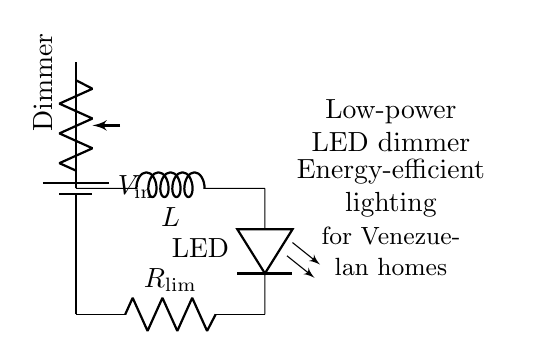What type of circuit is shown? The circuit presented is a dimmer circuit, specifically designed for controlling the brightness of an LED. It uses resistors and inductors to achieve dimming while conserving energy.
Answer: dimmer circuit What component limits the current to the LED? The component that limits the current flowing into the LED is the resistor specifically labeled as a current-limiting resistor. It ensures that the LED operates within safe current levels.
Answer: current-limiting resistor How many main components are in this circuit? There are four main components in the circuit: a battery, a potentiometer (dimmer), an inductor, and an LED with a current-limiting resistor. Each is essential for the functioning of the dimmer circuit.
Answer: four What is the function of the inductor in this circuit? The inductor in the circuit helps to smooth out the current flow to the LED, reducing flicker while providing stable brightness levels. Inductors store energy in a magnetic field, contributing to the efficiency of the lighting system.
Answer: smooth current flow How does the dimmer affect LED brightness? The dimmer potentiometer adjusts the resistance in the circuit, affecting the voltage drop across the LED. By changing the resistance, it controls how much current flows to the LED, thus varying its brightness.
Answer: controls brightness What does the LED symbolize in this circuit? The LED represents the light-emitting diode that provides illumination. Its position in the circuit indicates that it is the load being powered by the battery, and its brightness depends on the current flowing through it.
Answer: illumination 